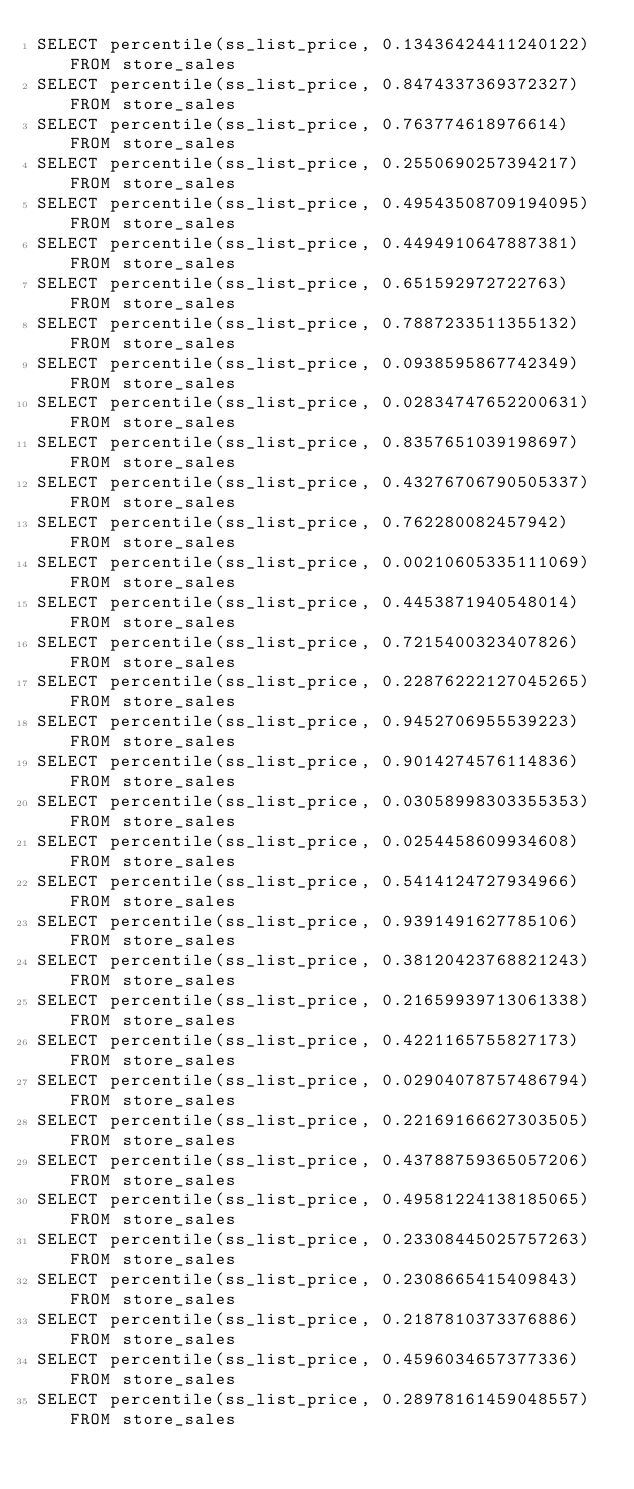<code> <loc_0><loc_0><loc_500><loc_500><_SQL_>SELECT percentile(ss_list_price, 0.13436424411240122) FROM store_sales
SELECT percentile(ss_list_price, 0.8474337369372327) FROM store_sales
SELECT percentile(ss_list_price, 0.763774618976614) FROM store_sales
SELECT percentile(ss_list_price, 0.2550690257394217) FROM store_sales
SELECT percentile(ss_list_price, 0.49543508709194095) FROM store_sales
SELECT percentile(ss_list_price, 0.4494910647887381) FROM store_sales
SELECT percentile(ss_list_price, 0.651592972722763) FROM store_sales
SELECT percentile(ss_list_price, 0.7887233511355132) FROM store_sales
SELECT percentile(ss_list_price, 0.0938595867742349) FROM store_sales
SELECT percentile(ss_list_price, 0.02834747652200631) FROM store_sales
SELECT percentile(ss_list_price, 0.8357651039198697) FROM store_sales
SELECT percentile(ss_list_price, 0.43276706790505337) FROM store_sales
SELECT percentile(ss_list_price, 0.762280082457942) FROM store_sales
SELECT percentile(ss_list_price, 0.00210605335111069) FROM store_sales
SELECT percentile(ss_list_price, 0.4453871940548014) FROM store_sales
SELECT percentile(ss_list_price, 0.7215400323407826) FROM store_sales
SELECT percentile(ss_list_price, 0.22876222127045265) FROM store_sales
SELECT percentile(ss_list_price, 0.9452706955539223) FROM store_sales
SELECT percentile(ss_list_price, 0.9014274576114836) FROM store_sales
SELECT percentile(ss_list_price, 0.03058998303355353) FROM store_sales
SELECT percentile(ss_list_price, 0.0254458609934608) FROM store_sales
SELECT percentile(ss_list_price, 0.5414124727934966) FROM store_sales
SELECT percentile(ss_list_price, 0.9391491627785106) FROM store_sales
SELECT percentile(ss_list_price, 0.38120423768821243) FROM store_sales
SELECT percentile(ss_list_price, 0.21659939713061338) FROM store_sales
SELECT percentile(ss_list_price, 0.4221165755827173) FROM store_sales
SELECT percentile(ss_list_price, 0.02904078757486794) FROM store_sales
SELECT percentile(ss_list_price, 0.22169166627303505) FROM store_sales
SELECT percentile(ss_list_price, 0.43788759365057206) FROM store_sales
SELECT percentile(ss_list_price, 0.49581224138185065) FROM store_sales
SELECT percentile(ss_list_price, 0.23308445025757263) FROM store_sales
SELECT percentile(ss_list_price, 0.2308665415409843) FROM store_sales
SELECT percentile(ss_list_price, 0.2187810373376886) FROM store_sales
SELECT percentile(ss_list_price, 0.4596034657377336) FROM store_sales
SELECT percentile(ss_list_price, 0.28978161459048557) FROM store_sales</code> 